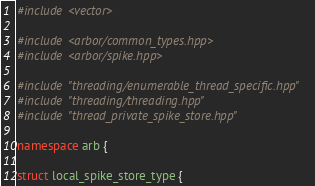Convert code to text. <code><loc_0><loc_0><loc_500><loc_500><_C++_>#include <vector>

#include <arbor/common_types.hpp>
#include <arbor/spike.hpp>

#include "threading/enumerable_thread_specific.hpp"
#include "threading/threading.hpp"
#include "thread_private_spike_store.hpp"

namespace arb {

struct local_spike_store_type {</code> 